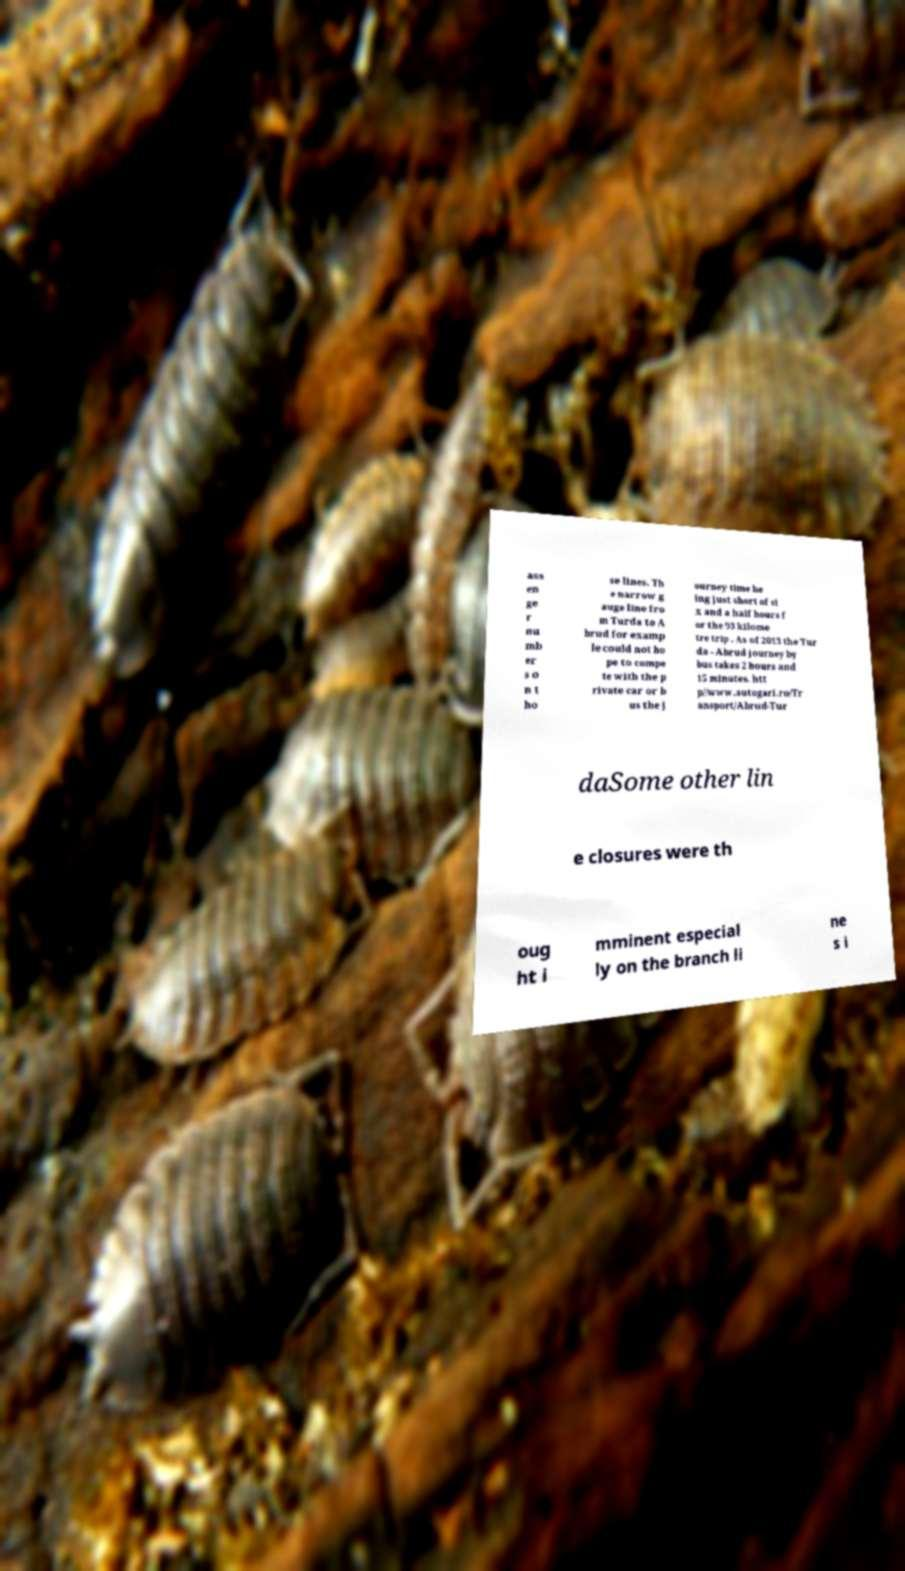Can you read and provide the text displayed in the image?This photo seems to have some interesting text. Can you extract and type it out for me? ass en ge r nu mb er s o n t ho se lines. Th e narrow g auge line fro m Turda to A brud for examp le could not ho pe to compe te with the p rivate car or b us the j ourney time be ing just short of si x and a half hours f or the 93 kilome tre trip . As of 2013 the Tur da - Abrud journey by bus takes 2 hours and 15 minutes. htt p//www.autogari.ro/Tr ansport/Abrud-Tur daSome other lin e closures were th oug ht i mminent especial ly on the branch li ne s i 